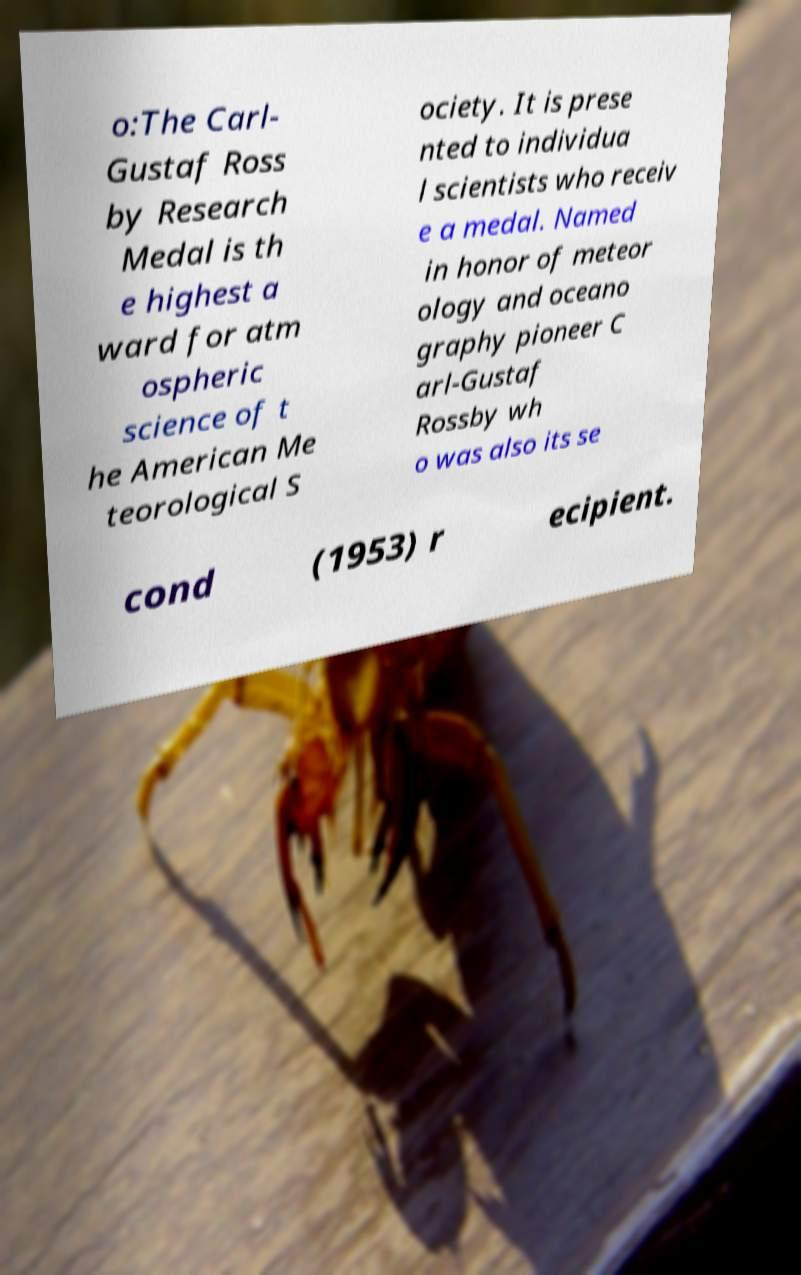What messages or text are displayed in this image? I need them in a readable, typed format. o:The Carl- Gustaf Ross by Research Medal is th e highest a ward for atm ospheric science of t he American Me teorological S ociety. It is prese nted to individua l scientists who receiv e a medal. Named in honor of meteor ology and oceano graphy pioneer C arl-Gustaf Rossby wh o was also its se cond (1953) r ecipient. 